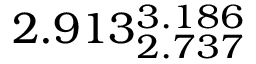Convert formula to latex. <formula><loc_0><loc_0><loc_500><loc_500>2 . 9 1 3 _ { 2 . 7 3 7 } ^ { 3 . 1 8 6 }</formula> 